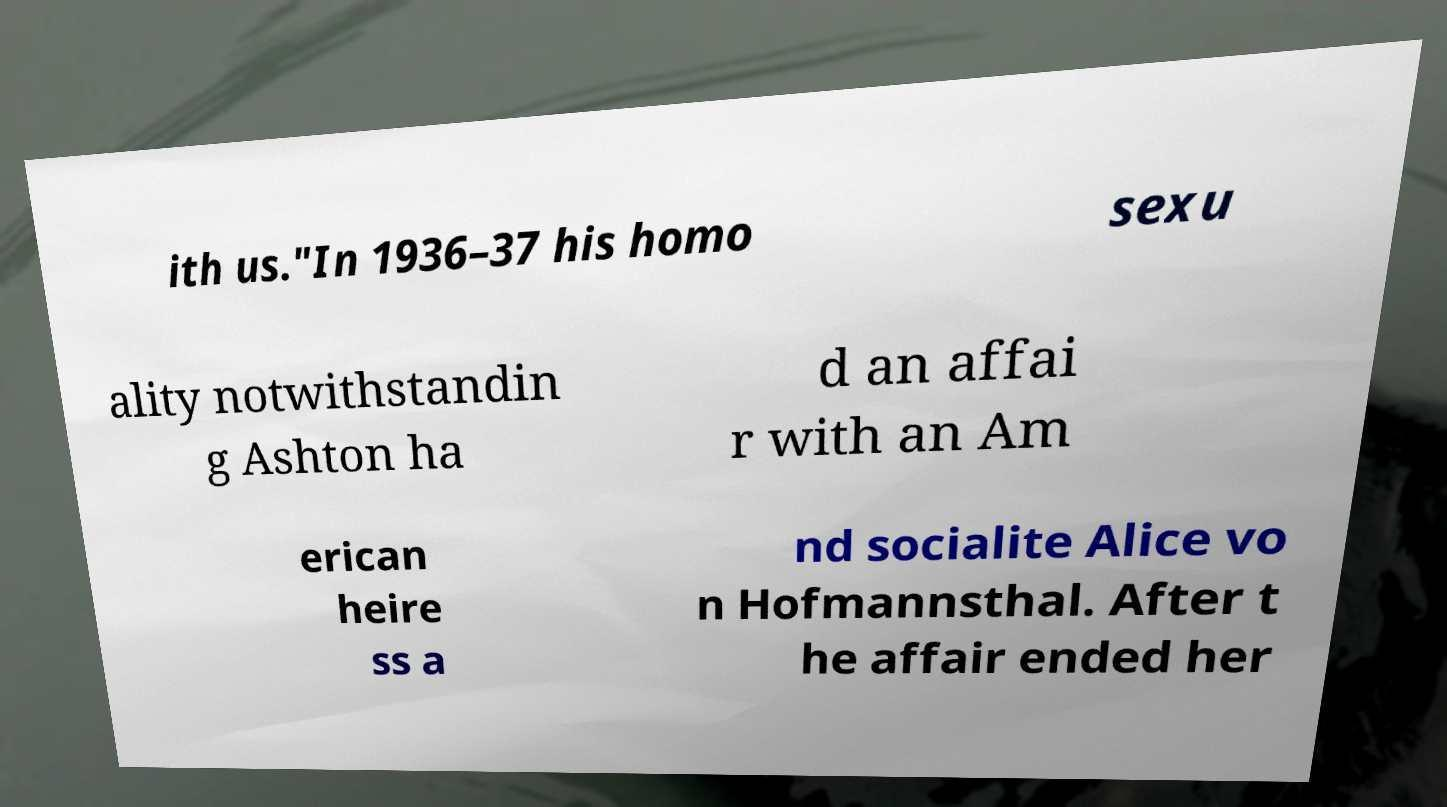Can you accurately transcribe the text from the provided image for me? ith us."In 1936–37 his homo sexu ality notwithstandin g Ashton ha d an affai r with an Am erican heire ss a nd socialite Alice vo n Hofmannsthal. After t he affair ended her 